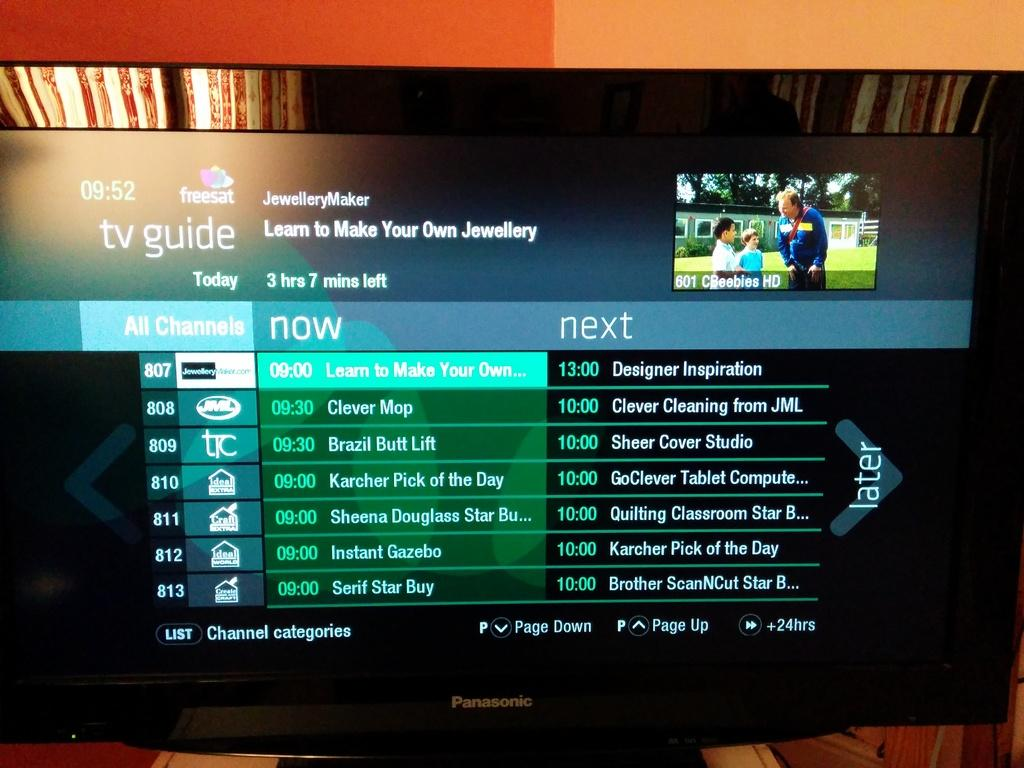Provide a one-sentence caption for the provided image. A Panasonic TV tuned into the TV Guide channel. 